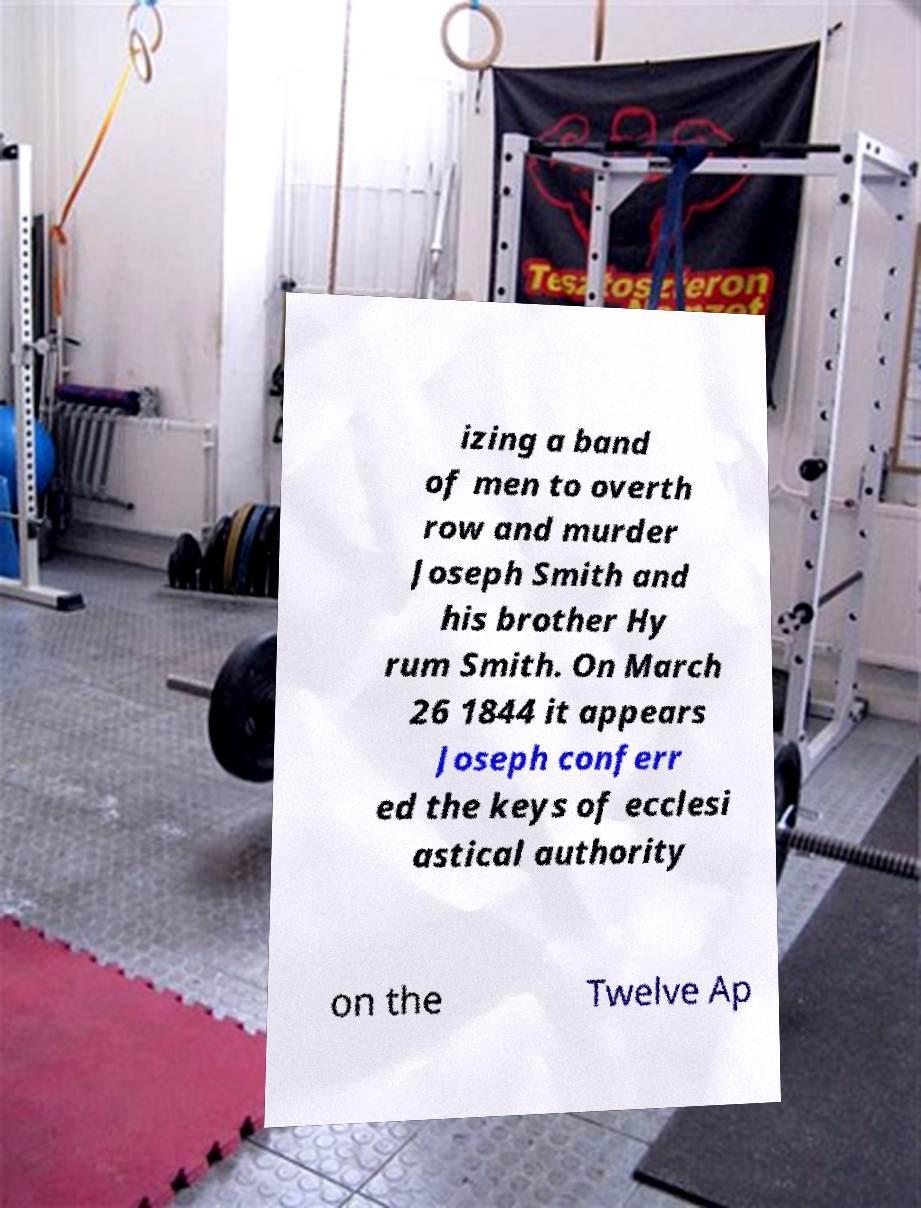Please identify and transcribe the text found in this image. izing a band of men to overth row and murder Joseph Smith and his brother Hy rum Smith. On March 26 1844 it appears Joseph conferr ed the keys of ecclesi astical authority on the Twelve Ap 